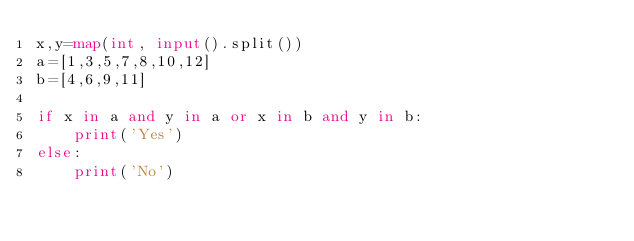Convert code to text. <code><loc_0><loc_0><loc_500><loc_500><_Python_>x,y=map(int, input().split())
a=[1,3,5,7,8,10,12]
b=[4,6,9,11]

if x in a and y in a or x in b and y in b:
    print('Yes')
else:
    print('No')</code> 